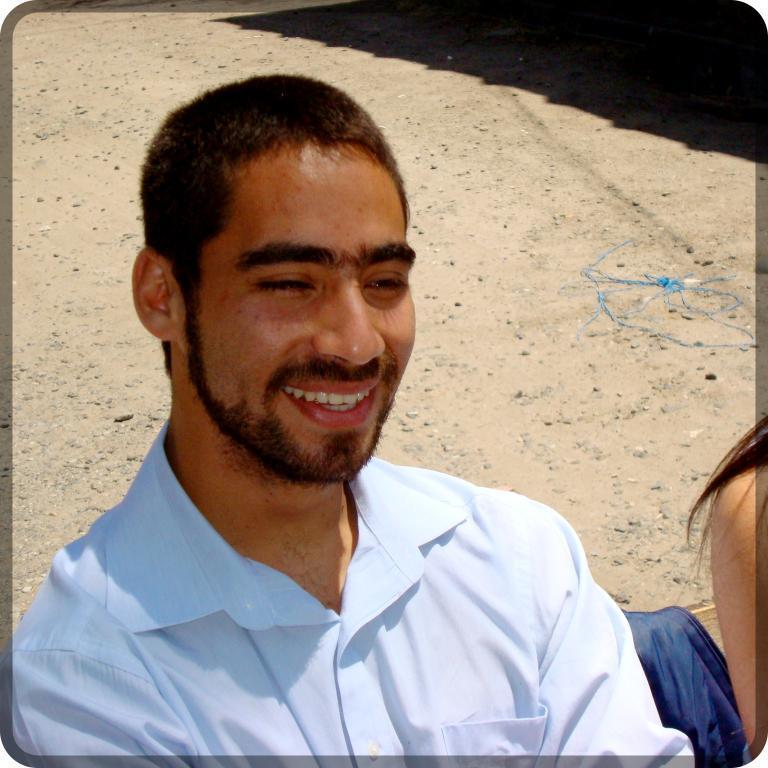Please provide a concise description of this image. As we can see in the image there is a man and a woman sitting on bench. In the background there is a shadow. 